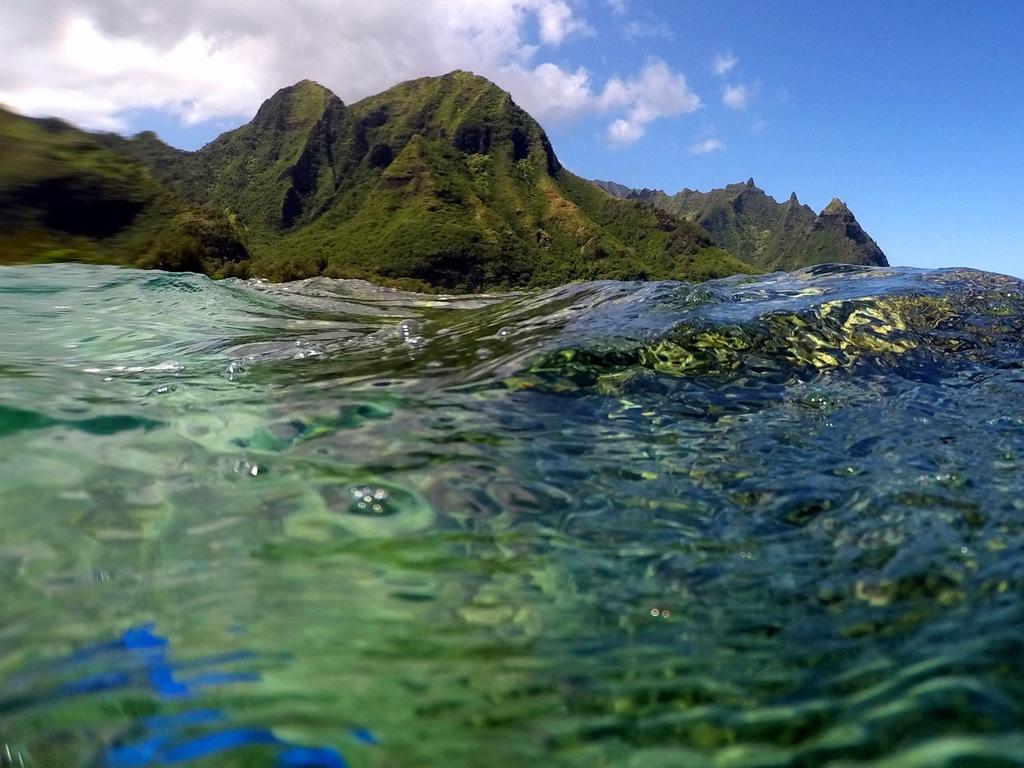In one or two sentences, can you explain what this image depicts? In this image we can see mountains. At the bottom of the image there is water. On the water we can see some reflections. At the top of the image there is the sky. 